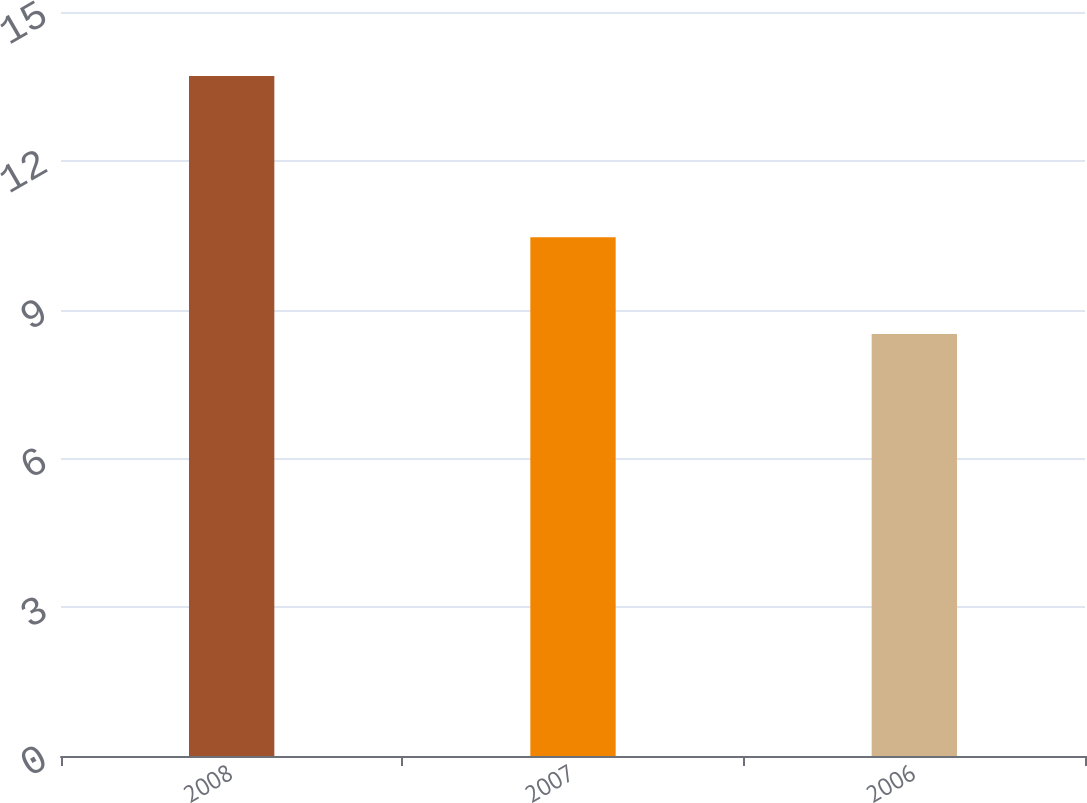Convert chart. <chart><loc_0><loc_0><loc_500><loc_500><bar_chart><fcel>2008<fcel>2007<fcel>2006<nl><fcel>13.71<fcel>10.46<fcel>8.51<nl></chart> 